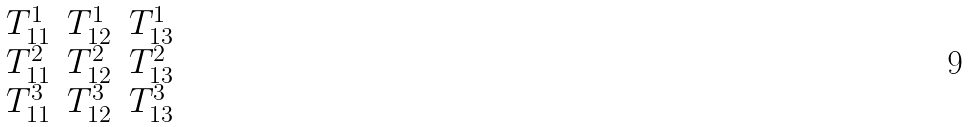Convert formula to latex. <formula><loc_0><loc_0><loc_500><loc_500>\begin{matrix} T ^ { 1 } _ { 1 1 } & T ^ { 1 } _ { 1 2 } & T ^ { 1 } _ { 1 3 } \\ T ^ { 2 } _ { 1 1 } & T ^ { 2 } _ { 1 2 } & T ^ { 2 } _ { 1 3 } \\ T ^ { 3 } _ { 1 1 } & T ^ { 3 } _ { 1 2 } & T ^ { 3 } _ { 1 3 } \end{matrix}</formula> 